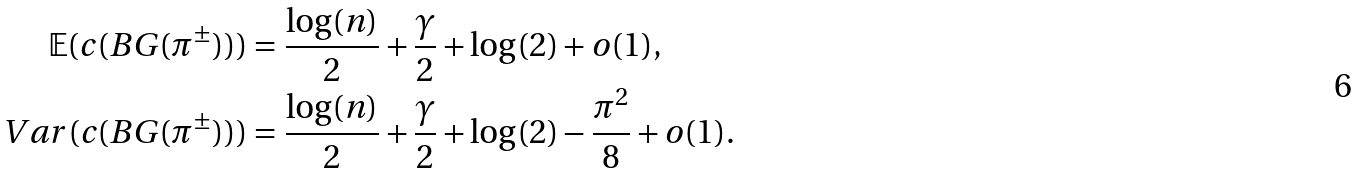<formula> <loc_0><loc_0><loc_500><loc_500>\mathbb { E } ( c ( B G ( \pi ^ { \pm } ) ) ) & = \frac { \log ( n ) } { 2 } + \frac { \gamma } { 2 } + \log ( 2 ) + o ( 1 ) , \\ V a r ( c ( B G ( \pi ^ { \pm } ) ) ) & = \frac { \log ( n ) } { 2 } + \frac { \gamma } { 2 } + \log ( 2 ) - \frac { \pi ^ { 2 } } { 8 } + o ( 1 ) .</formula> 